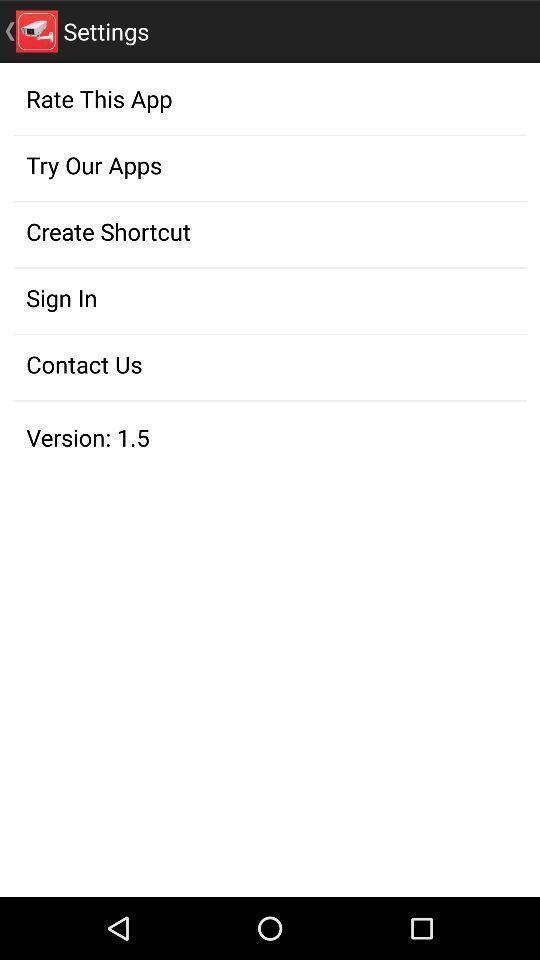Tell me about the visual elements in this screen capture. Page displaying the setting options an a app. 